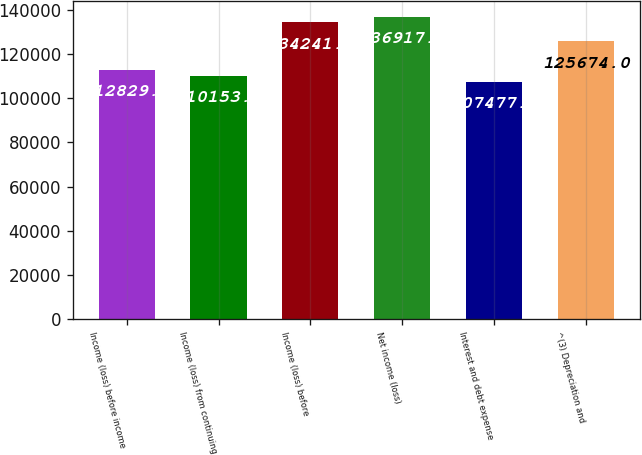<chart> <loc_0><loc_0><loc_500><loc_500><bar_chart><fcel>Income (loss) before income<fcel>Income (loss) from continuing<fcel>Income (loss) before<fcel>Net income (loss)<fcel>Interest and debt expense<fcel>^(3) Depreciation and<nl><fcel>112830<fcel>110153<fcel>134241<fcel>136917<fcel>107477<fcel>125674<nl></chart> 